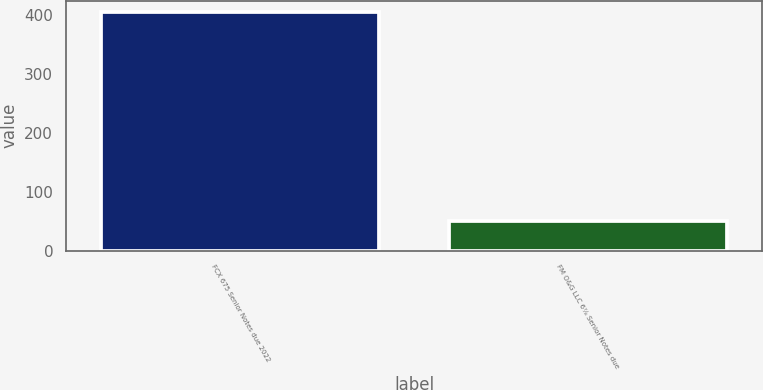Convert chart. <chart><loc_0><loc_0><loc_500><loc_500><bar_chart><fcel>FCX 675 Senior Notes due 2022<fcel>FM O&G LLC 6⅞ Senior Notes due<nl><fcel>404<fcel>50<nl></chart> 